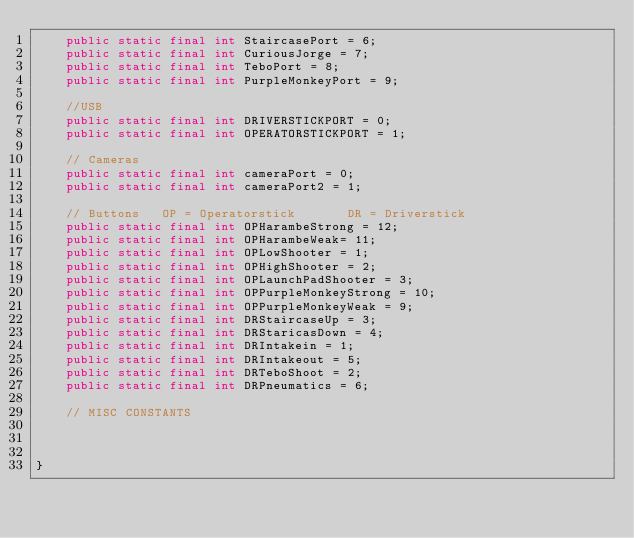<code> <loc_0><loc_0><loc_500><loc_500><_Java_>    public static final int StaircasePort = 6;
    public static final int CuriousJorge = 7;
    public static final int TeboPort = 8;
    public static final int PurpleMonkeyPort = 9;

    //USB      
    public static final int DRIVERSTICKPORT = 0;
    public static final int OPERATORSTICKPORT = 1;

    // Cameras
    public static final int cameraPort = 0;
    public static final int cameraPort2 = 1;

    // Buttons   OP = Operatorstick       DR = Driverstick
    public static final int OPHarambeStrong = 12;
    public static final int OPHarambeWeak= 11;
    public static final int OPLowShooter = 1;
    public static final int OPHighShooter = 2;
    public static final int OPLaunchPadShooter = 3; 
    public static final int OPPurpleMonkeyStrong = 10;
    public static final int OPPurpleMonkeyWeak = 9;
    public static final int DRStaircaseUp = 3;
    public static final int DRStaricasDown = 4;
    public static final int DRIntakein = 1;
    public static final int DRIntakeout = 5;
    public static final int DRTeboShoot = 2;
    public static final int DRPneumatics = 6;
    
    // MISC CONSTANTS
   


}</code> 